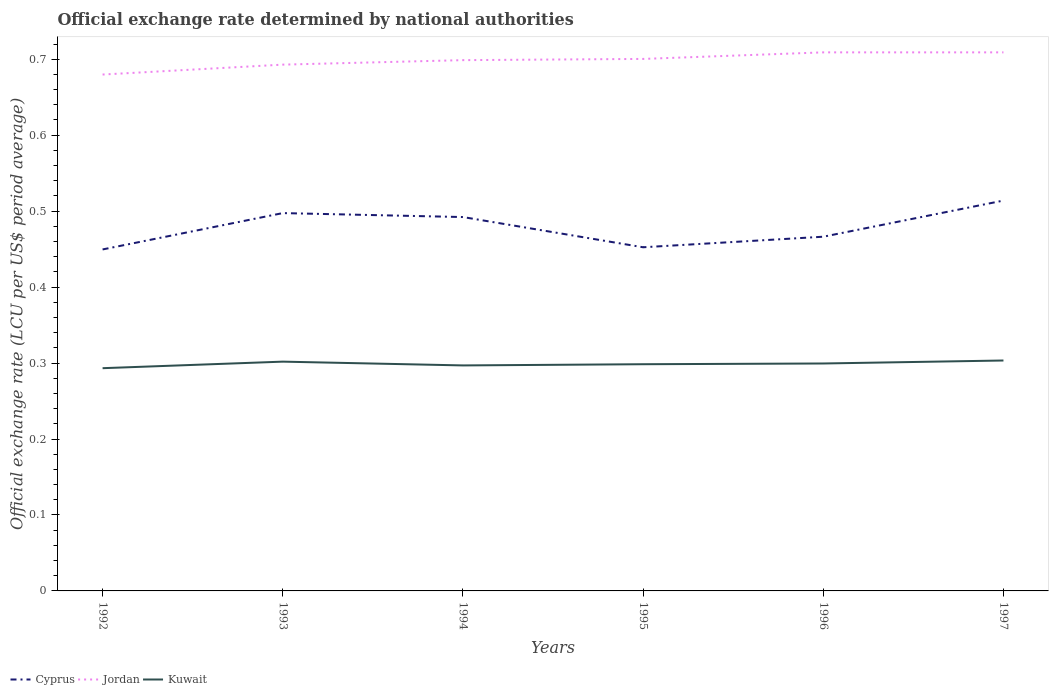Is the number of lines equal to the number of legend labels?
Offer a terse response. Yes. Across all years, what is the maximum official exchange rate in Cyprus?
Give a very brief answer. 0.45. In which year was the official exchange rate in Cyprus maximum?
Keep it short and to the point. 1992. What is the total official exchange rate in Cyprus in the graph?
Your answer should be compact. 0.01. What is the difference between the highest and the second highest official exchange rate in Cyprus?
Keep it short and to the point. 0.06. What is the difference between the highest and the lowest official exchange rate in Cyprus?
Your answer should be very brief. 3. Is the official exchange rate in Cyprus strictly greater than the official exchange rate in Jordan over the years?
Keep it short and to the point. Yes. How many lines are there?
Offer a terse response. 3. What is the difference between two consecutive major ticks on the Y-axis?
Your response must be concise. 0.1. Are the values on the major ticks of Y-axis written in scientific E-notation?
Provide a short and direct response. No. Does the graph contain grids?
Ensure brevity in your answer.  No. What is the title of the graph?
Ensure brevity in your answer.  Official exchange rate determined by national authorities. What is the label or title of the X-axis?
Offer a very short reply. Years. What is the label or title of the Y-axis?
Keep it short and to the point. Official exchange rate (LCU per US$ period average). What is the Official exchange rate (LCU per US$ period average) of Cyprus in 1992?
Give a very brief answer. 0.45. What is the Official exchange rate (LCU per US$ period average) of Jordan in 1992?
Give a very brief answer. 0.68. What is the Official exchange rate (LCU per US$ period average) of Kuwait in 1992?
Your answer should be compact. 0.29. What is the Official exchange rate (LCU per US$ period average) in Cyprus in 1993?
Provide a succinct answer. 0.5. What is the Official exchange rate (LCU per US$ period average) of Jordan in 1993?
Offer a terse response. 0.69. What is the Official exchange rate (LCU per US$ period average) of Kuwait in 1993?
Your response must be concise. 0.3. What is the Official exchange rate (LCU per US$ period average) in Cyprus in 1994?
Your response must be concise. 0.49. What is the Official exchange rate (LCU per US$ period average) in Jordan in 1994?
Keep it short and to the point. 0.7. What is the Official exchange rate (LCU per US$ period average) in Kuwait in 1994?
Your answer should be very brief. 0.3. What is the Official exchange rate (LCU per US$ period average) of Cyprus in 1995?
Provide a short and direct response. 0.45. What is the Official exchange rate (LCU per US$ period average) in Jordan in 1995?
Your answer should be compact. 0.7. What is the Official exchange rate (LCU per US$ period average) of Kuwait in 1995?
Make the answer very short. 0.3. What is the Official exchange rate (LCU per US$ period average) in Cyprus in 1996?
Offer a very short reply. 0.47. What is the Official exchange rate (LCU per US$ period average) in Jordan in 1996?
Keep it short and to the point. 0.71. What is the Official exchange rate (LCU per US$ period average) in Kuwait in 1996?
Ensure brevity in your answer.  0.3. What is the Official exchange rate (LCU per US$ period average) in Cyprus in 1997?
Your answer should be very brief. 0.51. What is the Official exchange rate (LCU per US$ period average) in Jordan in 1997?
Provide a succinct answer. 0.71. What is the Official exchange rate (LCU per US$ period average) in Kuwait in 1997?
Keep it short and to the point. 0.3. Across all years, what is the maximum Official exchange rate (LCU per US$ period average) of Cyprus?
Offer a terse response. 0.51. Across all years, what is the maximum Official exchange rate (LCU per US$ period average) of Jordan?
Ensure brevity in your answer.  0.71. Across all years, what is the maximum Official exchange rate (LCU per US$ period average) in Kuwait?
Provide a succinct answer. 0.3. Across all years, what is the minimum Official exchange rate (LCU per US$ period average) of Cyprus?
Make the answer very short. 0.45. Across all years, what is the minimum Official exchange rate (LCU per US$ period average) in Jordan?
Your response must be concise. 0.68. Across all years, what is the minimum Official exchange rate (LCU per US$ period average) in Kuwait?
Give a very brief answer. 0.29. What is the total Official exchange rate (LCU per US$ period average) of Cyprus in the graph?
Your answer should be very brief. 2.87. What is the total Official exchange rate (LCU per US$ period average) in Jordan in the graph?
Your answer should be very brief. 4.19. What is the total Official exchange rate (LCU per US$ period average) in Kuwait in the graph?
Keep it short and to the point. 1.79. What is the difference between the Official exchange rate (LCU per US$ period average) of Cyprus in 1992 and that in 1993?
Your answer should be compact. -0.05. What is the difference between the Official exchange rate (LCU per US$ period average) of Jordan in 1992 and that in 1993?
Give a very brief answer. -0.01. What is the difference between the Official exchange rate (LCU per US$ period average) in Kuwait in 1992 and that in 1993?
Give a very brief answer. -0.01. What is the difference between the Official exchange rate (LCU per US$ period average) in Cyprus in 1992 and that in 1994?
Your answer should be very brief. -0.04. What is the difference between the Official exchange rate (LCU per US$ period average) in Jordan in 1992 and that in 1994?
Provide a succinct answer. -0.02. What is the difference between the Official exchange rate (LCU per US$ period average) in Kuwait in 1992 and that in 1994?
Keep it short and to the point. -0. What is the difference between the Official exchange rate (LCU per US$ period average) in Cyprus in 1992 and that in 1995?
Provide a short and direct response. -0. What is the difference between the Official exchange rate (LCU per US$ period average) of Jordan in 1992 and that in 1995?
Keep it short and to the point. -0.02. What is the difference between the Official exchange rate (LCU per US$ period average) in Kuwait in 1992 and that in 1995?
Offer a very short reply. -0.01. What is the difference between the Official exchange rate (LCU per US$ period average) in Cyprus in 1992 and that in 1996?
Make the answer very short. -0.02. What is the difference between the Official exchange rate (LCU per US$ period average) of Jordan in 1992 and that in 1996?
Make the answer very short. -0.03. What is the difference between the Official exchange rate (LCU per US$ period average) in Kuwait in 1992 and that in 1996?
Offer a terse response. -0.01. What is the difference between the Official exchange rate (LCU per US$ period average) in Cyprus in 1992 and that in 1997?
Offer a terse response. -0.06. What is the difference between the Official exchange rate (LCU per US$ period average) of Jordan in 1992 and that in 1997?
Ensure brevity in your answer.  -0.03. What is the difference between the Official exchange rate (LCU per US$ period average) of Kuwait in 1992 and that in 1997?
Give a very brief answer. -0.01. What is the difference between the Official exchange rate (LCU per US$ period average) of Cyprus in 1993 and that in 1994?
Your answer should be compact. 0.01. What is the difference between the Official exchange rate (LCU per US$ period average) in Jordan in 1993 and that in 1994?
Offer a very short reply. -0.01. What is the difference between the Official exchange rate (LCU per US$ period average) of Kuwait in 1993 and that in 1994?
Offer a very short reply. 0.01. What is the difference between the Official exchange rate (LCU per US$ period average) of Cyprus in 1993 and that in 1995?
Your response must be concise. 0.04. What is the difference between the Official exchange rate (LCU per US$ period average) of Jordan in 1993 and that in 1995?
Ensure brevity in your answer.  -0.01. What is the difference between the Official exchange rate (LCU per US$ period average) of Kuwait in 1993 and that in 1995?
Give a very brief answer. 0. What is the difference between the Official exchange rate (LCU per US$ period average) in Cyprus in 1993 and that in 1996?
Make the answer very short. 0.03. What is the difference between the Official exchange rate (LCU per US$ period average) of Jordan in 1993 and that in 1996?
Your response must be concise. -0.02. What is the difference between the Official exchange rate (LCU per US$ period average) of Kuwait in 1993 and that in 1996?
Offer a terse response. 0. What is the difference between the Official exchange rate (LCU per US$ period average) of Cyprus in 1993 and that in 1997?
Your answer should be very brief. -0.02. What is the difference between the Official exchange rate (LCU per US$ period average) in Jordan in 1993 and that in 1997?
Your answer should be compact. -0.02. What is the difference between the Official exchange rate (LCU per US$ period average) in Kuwait in 1993 and that in 1997?
Offer a terse response. -0. What is the difference between the Official exchange rate (LCU per US$ period average) in Cyprus in 1994 and that in 1995?
Offer a terse response. 0.04. What is the difference between the Official exchange rate (LCU per US$ period average) in Jordan in 1994 and that in 1995?
Provide a short and direct response. -0. What is the difference between the Official exchange rate (LCU per US$ period average) in Kuwait in 1994 and that in 1995?
Your answer should be very brief. -0. What is the difference between the Official exchange rate (LCU per US$ period average) of Cyprus in 1994 and that in 1996?
Give a very brief answer. 0.03. What is the difference between the Official exchange rate (LCU per US$ period average) in Jordan in 1994 and that in 1996?
Provide a short and direct response. -0.01. What is the difference between the Official exchange rate (LCU per US$ period average) of Kuwait in 1994 and that in 1996?
Your answer should be compact. -0. What is the difference between the Official exchange rate (LCU per US$ period average) of Cyprus in 1994 and that in 1997?
Your answer should be very brief. -0.02. What is the difference between the Official exchange rate (LCU per US$ period average) in Jordan in 1994 and that in 1997?
Offer a very short reply. -0.01. What is the difference between the Official exchange rate (LCU per US$ period average) in Kuwait in 1994 and that in 1997?
Keep it short and to the point. -0.01. What is the difference between the Official exchange rate (LCU per US$ period average) in Cyprus in 1995 and that in 1996?
Keep it short and to the point. -0.01. What is the difference between the Official exchange rate (LCU per US$ period average) of Jordan in 1995 and that in 1996?
Offer a terse response. -0.01. What is the difference between the Official exchange rate (LCU per US$ period average) of Kuwait in 1995 and that in 1996?
Your response must be concise. -0. What is the difference between the Official exchange rate (LCU per US$ period average) of Cyprus in 1995 and that in 1997?
Your response must be concise. -0.06. What is the difference between the Official exchange rate (LCU per US$ period average) of Jordan in 1995 and that in 1997?
Your answer should be compact. -0.01. What is the difference between the Official exchange rate (LCU per US$ period average) in Kuwait in 1995 and that in 1997?
Give a very brief answer. -0. What is the difference between the Official exchange rate (LCU per US$ period average) in Cyprus in 1996 and that in 1997?
Your answer should be very brief. -0.05. What is the difference between the Official exchange rate (LCU per US$ period average) of Kuwait in 1996 and that in 1997?
Keep it short and to the point. -0. What is the difference between the Official exchange rate (LCU per US$ period average) in Cyprus in 1992 and the Official exchange rate (LCU per US$ period average) in Jordan in 1993?
Your answer should be very brief. -0.24. What is the difference between the Official exchange rate (LCU per US$ period average) of Cyprus in 1992 and the Official exchange rate (LCU per US$ period average) of Kuwait in 1993?
Provide a short and direct response. 0.15. What is the difference between the Official exchange rate (LCU per US$ period average) of Jordan in 1992 and the Official exchange rate (LCU per US$ period average) of Kuwait in 1993?
Your answer should be compact. 0.38. What is the difference between the Official exchange rate (LCU per US$ period average) in Cyprus in 1992 and the Official exchange rate (LCU per US$ period average) in Jordan in 1994?
Make the answer very short. -0.25. What is the difference between the Official exchange rate (LCU per US$ period average) of Cyprus in 1992 and the Official exchange rate (LCU per US$ period average) of Kuwait in 1994?
Give a very brief answer. 0.15. What is the difference between the Official exchange rate (LCU per US$ period average) of Jordan in 1992 and the Official exchange rate (LCU per US$ period average) of Kuwait in 1994?
Keep it short and to the point. 0.38. What is the difference between the Official exchange rate (LCU per US$ period average) in Cyprus in 1992 and the Official exchange rate (LCU per US$ period average) in Jordan in 1995?
Ensure brevity in your answer.  -0.25. What is the difference between the Official exchange rate (LCU per US$ period average) in Cyprus in 1992 and the Official exchange rate (LCU per US$ period average) in Kuwait in 1995?
Your response must be concise. 0.15. What is the difference between the Official exchange rate (LCU per US$ period average) in Jordan in 1992 and the Official exchange rate (LCU per US$ period average) in Kuwait in 1995?
Offer a terse response. 0.38. What is the difference between the Official exchange rate (LCU per US$ period average) of Cyprus in 1992 and the Official exchange rate (LCU per US$ period average) of Jordan in 1996?
Your response must be concise. -0.26. What is the difference between the Official exchange rate (LCU per US$ period average) in Cyprus in 1992 and the Official exchange rate (LCU per US$ period average) in Kuwait in 1996?
Your answer should be compact. 0.15. What is the difference between the Official exchange rate (LCU per US$ period average) in Jordan in 1992 and the Official exchange rate (LCU per US$ period average) in Kuwait in 1996?
Make the answer very short. 0.38. What is the difference between the Official exchange rate (LCU per US$ period average) in Cyprus in 1992 and the Official exchange rate (LCU per US$ period average) in Jordan in 1997?
Offer a very short reply. -0.26. What is the difference between the Official exchange rate (LCU per US$ period average) of Cyprus in 1992 and the Official exchange rate (LCU per US$ period average) of Kuwait in 1997?
Give a very brief answer. 0.15. What is the difference between the Official exchange rate (LCU per US$ period average) of Jordan in 1992 and the Official exchange rate (LCU per US$ period average) of Kuwait in 1997?
Offer a very short reply. 0.38. What is the difference between the Official exchange rate (LCU per US$ period average) of Cyprus in 1993 and the Official exchange rate (LCU per US$ period average) of Jordan in 1994?
Your answer should be compact. -0.2. What is the difference between the Official exchange rate (LCU per US$ period average) of Cyprus in 1993 and the Official exchange rate (LCU per US$ period average) of Kuwait in 1994?
Provide a succinct answer. 0.2. What is the difference between the Official exchange rate (LCU per US$ period average) of Jordan in 1993 and the Official exchange rate (LCU per US$ period average) of Kuwait in 1994?
Your answer should be compact. 0.4. What is the difference between the Official exchange rate (LCU per US$ period average) in Cyprus in 1993 and the Official exchange rate (LCU per US$ period average) in Jordan in 1995?
Provide a short and direct response. -0.2. What is the difference between the Official exchange rate (LCU per US$ period average) in Cyprus in 1993 and the Official exchange rate (LCU per US$ period average) in Kuwait in 1995?
Your answer should be very brief. 0.2. What is the difference between the Official exchange rate (LCU per US$ period average) of Jordan in 1993 and the Official exchange rate (LCU per US$ period average) of Kuwait in 1995?
Your answer should be very brief. 0.39. What is the difference between the Official exchange rate (LCU per US$ period average) in Cyprus in 1993 and the Official exchange rate (LCU per US$ period average) in Jordan in 1996?
Keep it short and to the point. -0.21. What is the difference between the Official exchange rate (LCU per US$ period average) in Cyprus in 1993 and the Official exchange rate (LCU per US$ period average) in Kuwait in 1996?
Your response must be concise. 0.2. What is the difference between the Official exchange rate (LCU per US$ period average) of Jordan in 1993 and the Official exchange rate (LCU per US$ period average) of Kuwait in 1996?
Provide a short and direct response. 0.39. What is the difference between the Official exchange rate (LCU per US$ period average) in Cyprus in 1993 and the Official exchange rate (LCU per US$ period average) in Jordan in 1997?
Offer a terse response. -0.21. What is the difference between the Official exchange rate (LCU per US$ period average) in Cyprus in 1993 and the Official exchange rate (LCU per US$ period average) in Kuwait in 1997?
Provide a succinct answer. 0.19. What is the difference between the Official exchange rate (LCU per US$ period average) of Jordan in 1993 and the Official exchange rate (LCU per US$ period average) of Kuwait in 1997?
Ensure brevity in your answer.  0.39. What is the difference between the Official exchange rate (LCU per US$ period average) of Cyprus in 1994 and the Official exchange rate (LCU per US$ period average) of Jordan in 1995?
Offer a very short reply. -0.21. What is the difference between the Official exchange rate (LCU per US$ period average) in Cyprus in 1994 and the Official exchange rate (LCU per US$ period average) in Kuwait in 1995?
Ensure brevity in your answer.  0.19. What is the difference between the Official exchange rate (LCU per US$ period average) of Jordan in 1994 and the Official exchange rate (LCU per US$ period average) of Kuwait in 1995?
Offer a terse response. 0.4. What is the difference between the Official exchange rate (LCU per US$ period average) in Cyprus in 1994 and the Official exchange rate (LCU per US$ period average) in Jordan in 1996?
Your response must be concise. -0.22. What is the difference between the Official exchange rate (LCU per US$ period average) in Cyprus in 1994 and the Official exchange rate (LCU per US$ period average) in Kuwait in 1996?
Your response must be concise. 0.19. What is the difference between the Official exchange rate (LCU per US$ period average) of Jordan in 1994 and the Official exchange rate (LCU per US$ period average) of Kuwait in 1996?
Your response must be concise. 0.4. What is the difference between the Official exchange rate (LCU per US$ period average) in Cyprus in 1994 and the Official exchange rate (LCU per US$ period average) in Jordan in 1997?
Ensure brevity in your answer.  -0.22. What is the difference between the Official exchange rate (LCU per US$ period average) in Cyprus in 1994 and the Official exchange rate (LCU per US$ period average) in Kuwait in 1997?
Offer a very short reply. 0.19. What is the difference between the Official exchange rate (LCU per US$ period average) of Jordan in 1994 and the Official exchange rate (LCU per US$ period average) of Kuwait in 1997?
Your answer should be very brief. 0.4. What is the difference between the Official exchange rate (LCU per US$ period average) in Cyprus in 1995 and the Official exchange rate (LCU per US$ period average) in Jordan in 1996?
Offer a terse response. -0.26. What is the difference between the Official exchange rate (LCU per US$ period average) of Cyprus in 1995 and the Official exchange rate (LCU per US$ period average) of Kuwait in 1996?
Your answer should be compact. 0.15. What is the difference between the Official exchange rate (LCU per US$ period average) of Jordan in 1995 and the Official exchange rate (LCU per US$ period average) of Kuwait in 1996?
Make the answer very short. 0.4. What is the difference between the Official exchange rate (LCU per US$ period average) of Cyprus in 1995 and the Official exchange rate (LCU per US$ period average) of Jordan in 1997?
Provide a short and direct response. -0.26. What is the difference between the Official exchange rate (LCU per US$ period average) of Cyprus in 1995 and the Official exchange rate (LCU per US$ period average) of Kuwait in 1997?
Ensure brevity in your answer.  0.15. What is the difference between the Official exchange rate (LCU per US$ period average) in Jordan in 1995 and the Official exchange rate (LCU per US$ period average) in Kuwait in 1997?
Ensure brevity in your answer.  0.4. What is the difference between the Official exchange rate (LCU per US$ period average) of Cyprus in 1996 and the Official exchange rate (LCU per US$ period average) of Jordan in 1997?
Ensure brevity in your answer.  -0.24. What is the difference between the Official exchange rate (LCU per US$ period average) of Cyprus in 1996 and the Official exchange rate (LCU per US$ period average) of Kuwait in 1997?
Provide a succinct answer. 0.16. What is the difference between the Official exchange rate (LCU per US$ period average) of Jordan in 1996 and the Official exchange rate (LCU per US$ period average) of Kuwait in 1997?
Offer a terse response. 0.41. What is the average Official exchange rate (LCU per US$ period average) of Cyprus per year?
Make the answer very short. 0.48. What is the average Official exchange rate (LCU per US$ period average) in Jordan per year?
Offer a terse response. 0.7. What is the average Official exchange rate (LCU per US$ period average) in Kuwait per year?
Provide a succinct answer. 0.3. In the year 1992, what is the difference between the Official exchange rate (LCU per US$ period average) in Cyprus and Official exchange rate (LCU per US$ period average) in Jordan?
Make the answer very short. -0.23. In the year 1992, what is the difference between the Official exchange rate (LCU per US$ period average) in Cyprus and Official exchange rate (LCU per US$ period average) in Kuwait?
Make the answer very short. 0.16. In the year 1992, what is the difference between the Official exchange rate (LCU per US$ period average) in Jordan and Official exchange rate (LCU per US$ period average) in Kuwait?
Give a very brief answer. 0.39. In the year 1993, what is the difference between the Official exchange rate (LCU per US$ period average) in Cyprus and Official exchange rate (LCU per US$ period average) in Jordan?
Provide a short and direct response. -0.2. In the year 1993, what is the difference between the Official exchange rate (LCU per US$ period average) of Cyprus and Official exchange rate (LCU per US$ period average) of Kuwait?
Your answer should be compact. 0.2. In the year 1993, what is the difference between the Official exchange rate (LCU per US$ period average) of Jordan and Official exchange rate (LCU per US$ period average) of Kuwait?
Keep it short and to the point. 0.39. In the year 1994, what is the difference between the Official exchange rate (LCU per US$ period average) in Cyprus and Official exchange rate (LCU per US$ period average) in Jordan?
Your answer should be compact. -0.21. In the year 1994, what is the difference between the Official exchange rate (LCU per US$ period average) of Cyprus and Official exchange rate (LCU per US$ period average) of Kuwait?
Make the answer very short. 0.2. In the year 1994, what is the difference between the Official exchange rate (LCU per US$ period average) of Jordan and Official exchange rate (LCU per US$ period average) of Kuwait?
Provide a succinct answer. 0.4. In the year 1995, what is the difference between the Official exchange rate (LCU per US$ period average) of Cyprus and Official exchange rate (LCU per US$ period average) of Jordan?
Offer a terse response. -0.25. In the year 1995, what is the difference between the Official exchange rate (LCU per US$ period average) in Cyprus and Official exchange rate (LCU per US$ period average) in Kuwait?
Your answer should be very brief. 0.15. In the year 1995, what is the difference between the Official exchange rate (LCU per US$ period average) of Jordan and Official exchange rate (LCU per US$ period average) of Kuwait?
Your response must be concise. 0.4. In the year 1996, what is the difference between the Official exchange rate (LCU per US$ period average) of Cyprus and Official exchange rate (LCU per US$ period average) of Jordan?
Ensure brevity in your answer.  -0.24. In the year 1996, what is the difference between the Official exchange rate (LCU per US$ period average) in Cyprus and Official exchange rate (LCU per US$ period average) in Kuwait?
Your answer should be very brief. 0.17. In the year 1996, what is the difference between the Official exchange rate (LCU per US$ period average) of Jordan and Official exchange rate (LCU per US$ period average) of Kuwait?
Your answer should be compact. 0.41. In the year 1997, what is the difference between the Official exchange rate (LCU per US$ period average) in Cyprus and Official exchange rate (LCU per US$ period average) in Jordan?
Offer a very short reply. -0.2. In the year 1997, what is the difference between the Official exchange rate (LCU per US$ period average) of Cyprus and Official exchange rate (LCU per US$ period average) of Kuwait?
Your answer should be very brief. 0.21. In the year 1997, what is the difference between the Official exchange rate (LCU per US$ period average) of Jordan and Official exchange rate (LCU per US$ period average) of Kuwait?
Your response must be concise. 0.41. What is the ratio of the Official exchange rate (LCU per US$ period average) in Cyprus in 1992 to that in 1993?
Keep it short and to the point. 0.9. What is the ratio of the Official exchange rate (LCU per US$ period average) of Jordan in 1992 to that in 1993?
Provide a short and direct response. 0.98. What is the ratio of the Official exchange rate (LCU per US$ period average) in Kuwait in 1992 to that in 1993?
Ensure brevity in your answer.  0.97. What is the ratio of the Official exchange rate (LCU per US$ period average) in Cyprus in 1992 to that in 1994?
Your answer should be compact. 0.91. What is the ratio of the Official exchange rate (LCU per US$ period average) in Jordan in 1992 to that in 1994?
Ensure brevity in your answer.  0.97. What is the ratio of the Official exchange rate (LCU per US$ period average) of Kuwait in 1992 to that in 1994?
Make the answer very short. 0.99. What is the ratio of the Official exchange rate (LCU per US$ period average) in Cyprus in 1992 to that in 1995?
Your answer should be compact. 0.99. What is the ratio of the Official exchange rate (LCU per US$ period average) in Jordan in 1992 to that in 1995?
Your answer should be compact. 0.97. What is the ratio of the Official exchange rate (LCU per US$ period average) of Kuwait in 1992 to that in 1995?
Provide a short and direct response. 0.98. What is the ratio of the Official exchange rate (LCU per US$ period average) of Cyprus in 1992 to that in 1996?
Your response must be concise. 0.96. What is the ratio of the Official exchange rate (LCU per US$ period average) in Jordan in 1992 to that in 1996?
Your answer should be very brief. 0.96. What is the ratio of the Official exchange rate (LCU per US$ period average) in Kuwait in 1992 to that in 1996?
Keep it short and to the point. 0.98. What is the ratio of the Official exchange rate (LCU per US$ period average) of Cyprus in 1992 to that in 1997?
Give a very brief answer. 0.87. What is the ratio of the Official exchange rate (LCU per US$ period average) in Jordan in 1992 to that in 1997?
Give a very brief answer. 0.96. What is the ratio of the Official exchange rate (LCU per US$ period average) in Kuwait in 1992 to that in 1997?
Make the answer very short. 0.97. What is the ratio of the Official exchange rate (LCU per US$ period average) of Cyprus in 1993 to that in 1994?
Offer a terse response. 1.01. What is the ratio of the Official exchange rate (LCU per US$ period average) in Kuwait in 1993 to that in 1994?
Offer a very short reply. 1.02. What is the ratio of the Official exchange rate (LCU per US$ period average) in Cyprus in 1993 to that in 1995?
Ensure brevity in your answer.  1.1. What is the ratio of the Official exchange rate (LCU per US$ period average) of Jordan in 1993 to that in 1995?
Give a very brief answer. 0.99. What is the ratio of the Official exchange rate (LCU per US$ period average) of Kuwait in 1993 to that in 1995?
Your answer should be compact. 1.01. What is the ratio of the Official exchange rate (LCU per US$ period average) of Cyprus in 1993 to that in 1996?
Offer a very short reply. 1.07. What is the ratio of the Official exchange rate (LCU per US$ period average) of Jordan in 1993 to that in 1996?
Keep it short and to the point. 0.98. What is the ratio of the Official exchange rate (LCU per US$ period average) in Kuwait in 1993 to that in 1996?
Make the answer very short. 1.01. What is the ratio of the Official exchange rate (LCU per US$ period average) of Cyprus in 1993 to that in 1997?
Offer a very short reply. 0.97. What is the ratio of the Official exchange rate (LCU per US$ period average) in Jordan in 1993 to that in 1997?
Provide a short and direct response. 0.98. What is the ratio of the Official exchange rate (LCU per US$ period average) in Cyprus in 1994 to that in 1995?
Provide a short and direct response. 1.09. What is the ratio of the Official exchange rate (LCU per US$ period average) of Jordan in 1994 to that in 1995?
Your answer should be very brief. 1. What is the ratio of the Official exchange rate (LCU per US$ period average) of Kuwait in 1994 to that in 1995?
Your answer should be very brief. 0.99. What is the ratio of the Official exchange rate (LCU per US$ period average) in Cyprus in 1994 to that in 1996?
Provide a short and direct response. 1.06. What is the ratio of the Official exchange rate (LCU per US$ period average) in Jordan in 1994 to that in 1996?
Make the answer very short. 0.99. What is the ratio of the Official exchange rate (LCU per US$ period average) of Kuwait in 1994 to that in 1996?
Provide a succinct answer. 0.99. What is the ratio of the Official exchange rate (LCU per US$ period average) of Cyprus in 1994 to that in 1997?
Your answer should be compact. 0.96. What is the ratio of the Official exchange rate (LCU per US$ period average) of Jordan in 1994 to that in 1997?
Your answer should be very brief. 0.99. What is the ratio of the Official exchange rate (LCU per US$ period average) of Kuwait in 1994 to that in 1997?
Give a very brief answer. 0.98. What is the ratio of the Official exchange rate (LCU per US$ period average) of Cyprus in 1995 to that in 1996?
Give a very brief answer. 0.97. What is the ratio of the Official exchange rate (LCU per US$ period average) of Jordan in 1995 to that in 1996?
Provide a short and direct response. 0.99. What is the ratio of the Official exchange rate (LCU per US$ period average) in Kuwait in 1995 to that in 1996?
Offer a terse response. 1. What is the ratio of the Official exchange rate (LCU per US$ period average) of Cyprus in 1995 to that in 1997?
Make the answer very short. 0.88. What is the ratio of the Official exchange rate (LCU per US$ period average) in Jordan in 1995 to that in 1997?
Provide a succinct answer. 0.99. What is the ratio of the Official exchange rate (LCU per US$ period average) of Kuwait in 1995 to that in 1997?
Your answer should be compact. 0.98. What is the ratio of the Official exchange rate (LCU per US$ period average) of Cyprus in 1996 to that in 1997?
Your answer should be very brief. 0.91. What is the ratio of the Official exchange rate (LCU per US$ period average) of Jordan in 1996 to that in 1997?
Your response must be concise. 1. What is the difference between the highest and the second highest Official exchange rate (LCU per US$ period average) of Cyprus?
Make the answer very short. 0.02. What is the difference between the highest and the second highest Official exchange rate (LCU per US$ period average) in Jordan?
Make the answer very short. 0. What is the difference between the highest and the second highest Official exchange rate (LCU per US$ period average) in Kuwait?
Your answer should be very brief. 0. What is the difference between the highest and the lowest Official exchange rate (LCU per US$ period average) in Cyprus?
Your answer should be very brief. 0.06. What is the difference between the highest and the lowest Official exchange rate (LCU per US$ period average) in Jordan?
Offer a very short reply. 0.03. What is the difference between the highest and the lowest Official exchange rate (LCU per US$ period average) in Kuwait?
Provide a short and direct response. 0.01. 